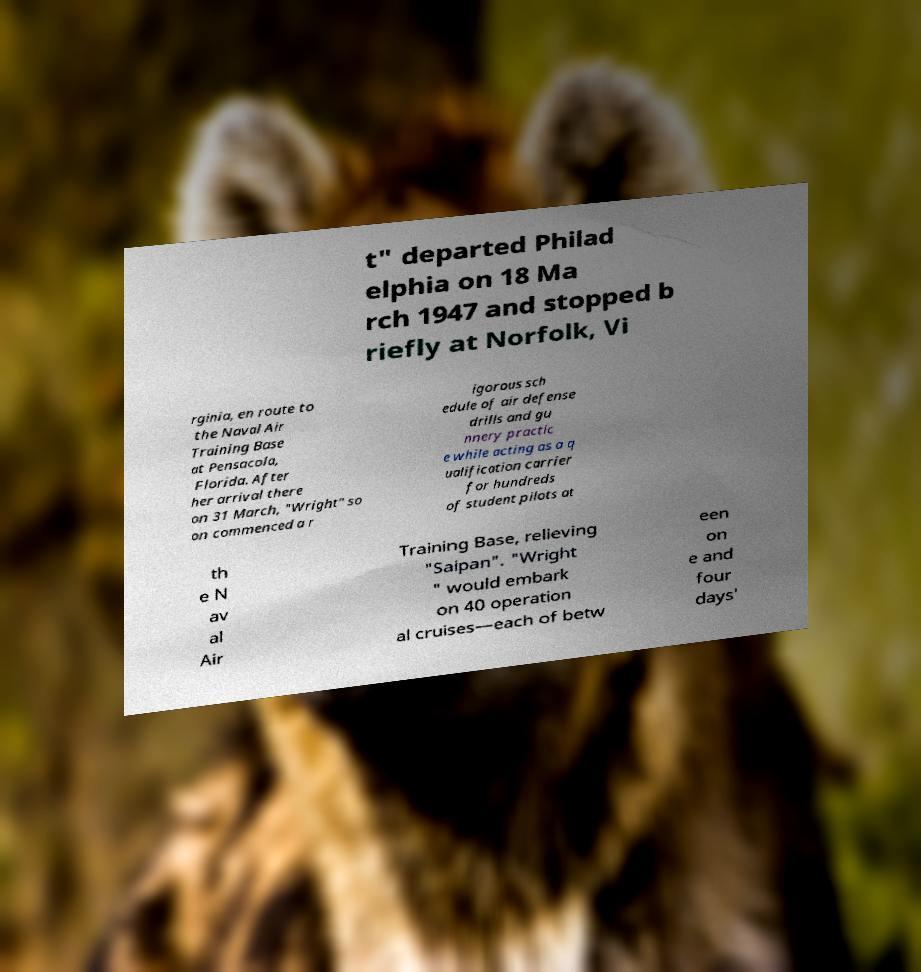I need the written content from this picture converted into text. Can you do that? t" departed Philad elphia on 18 Ma rch 1947 and stopped b riefly at Norfolk, Vi rginia, en route to the Naval Air Training Base at Pensacola, Florida. After her arrival there on 31 March, "Wright" so on commenced a r igorous sch edule of air defense drills and gu nnery practic e while acting as a q ualification carrier for hundreds of student pilots at th e N av al Air Training Base, relieving "Saipan". "Wright " would embark on 40 operation al cruises—each of betw een on e and four days' 